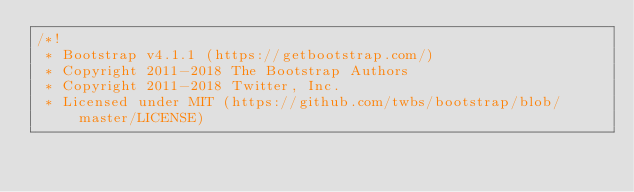<code> <loc_0><loc_0><loc_500><loc_500><_CSS_>/*!
 * Bootstrap v4.1.1 (https://getbootstrap.com/)
 * Copyright 2011-2018 The Bootstrap Authors
 * Copyright 2011-2018 Twitter, Inc.
 * Licensed under MIT (https://github.com/twbs/bootstrap/blob/master/LICENSE)</code> 